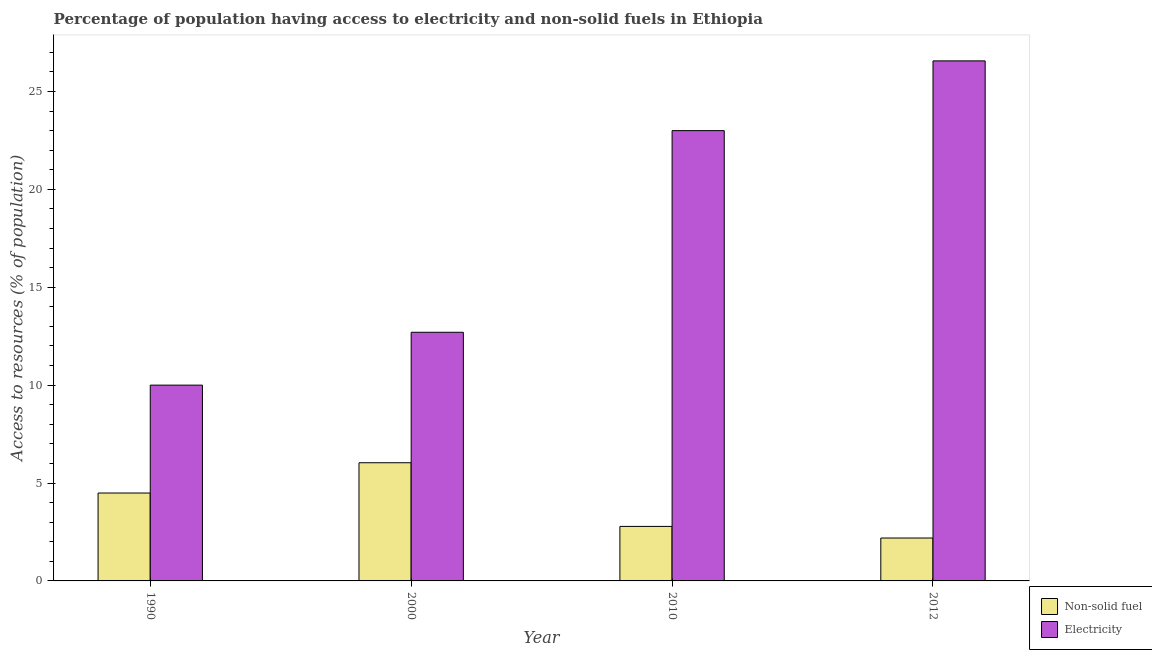Are the number of bars on each tick of the X-axis equal?
Your answer should be very brief. Yes. In how many cases, is the number of bars for a given year not equal to the number of legend labels?
Provide a succinct answer. 0. What is the percentage of population having access to non-solid fuel in 2010?
Make the answer very short. 2.78. Across all years, what is the maximum percentage of population having access to electricity?
Ensure brevity in your answer.  26.56. Across all years, what is the minimum percentage of population having access to electricity?
Offer a very short reply. 10. In which year was the percentage of population having access to electricity maximum?
Your response must be concise. 2012. What is the total percentage of population having access to non-solid fuel in the graph?
Provide a succinct answer. 15.5. What is the difference between the percentage of population having access to non-solid fuel in 1990 and that in 2012?
Ensure brevity in your answer.  2.3. What is the difference between the percentage of population having access to non-solid fuel in 1990 and the percentage of population having access to electricity in 2012?
Keep it short and to the point. 2.3. What is the average percentage of population having access to electricity per year?
Provide a succinct answer. 18.07. What is the ratio of the percentage of population having access to electricity in 1990 to that in 2012?
Your answer should be very brief. 0.38. What is the difference between the highest and the second highest percentage of population having access to non-solid fuel?
Ensure brevity in your answer.  1.55. What is the difference between the highest and the lowest percentage of population having access to electricity?
Offer a terse response. 16.56. In how many years, is the percentage of population having access to non-solid fuel greater than the average percentage of population having access to non-solid fuel taken over all years?
Provide a short and direct response. 2. What does the 2nd bar from the left in 2000 represents?
Provide a succinct answer. Electricity. What does the 2nd bar from the right in 1990 represents?
Offer a terse response. Non-solid fuel. How many bars are there?
Your answer should be very brief. 8. Are the values on the major ticks of Y-axis written in scientific E-notation?
Provide a succinct answer. No. Does the graph contain any zero values?
Offer a very short reply. No. How are the legend labels stacked?
Make the answer very short. Vertical. What is the title of the graph?
Provide a succinct answer. Percentage of population having access to electricity and non-solid fuels in Ethiopia. Does "Education" appear as one of the legend labels in the graph?
Offer a terse response. No. What is the label or title of the X-axis?
Your response must be concise. Year. What is the label or title of the Y-axis?
Keep it short and to the point. Access to resources (% of population). What is the Access to resources (% of population) in Non-solid fuel in 1990?
Your answer should be very brief. 4.49. What is the Access to resources (% of population) of Electricity in 1990?
Keep it short and to the point. 10. What is the Access to resources (% of population) of Non-solid fuel in 2000?
Your answer should be very brief. 6.04. What is the Access to resources (% of population) in Non-solid fuel in 2010?
Offer a terse response. 2.78. What is the Access to resources (% of population) of Electricity in 2010?
Offer a very short reply. 23. What is the Access to resources (% of population) in Non-solid fuel in 2012?
Your answer should be compact. 2.19. What is the Access to resources (% of population) of Electricity in 2012?
Your answer should be very brief. 26.56. Across all years, what is the maximum Access to resources (% of population) of Non-solid fuel?
Your answer should be compact. 6.04. Across all years, what is the maximum Access to resources (% of population) of Electricity?
Provide a short and direct response. 26.56. Across all years, what is the minimum Access to resources (% of population) in Non-solid fuel?
Offer a very short reply. 2.19. What is the total Access to resources (% of population) in Non-solid fuel in the graph?
Give a very brief answer. 15.5. What is the total Access to resources (% of population) in Electricity in the graph?
Make the answer very short. 72.26. What is the difference between the Access to resources (% of population) in Non-solid fuel in 1990 and that in 2000?
Provide a succinct answer. -1.55. What is the difference between the Access to resources (% of population) of Non-solid fuel in 1990 and that in 2010?
Your answer should be very brief. 1.71. What is the difference between the Access to resources (% of population) of Electricity in 1990 and that in 2010?
Offer a terse response. -13. What is the difference between the Access to resources (% of population) in Non-solid fuel in 1990 and that in 2012?
Your answer should be very brief. 2.3. What is the difference between the Access to resources (% of population) of Electricity in 1990 and that in 2012?
Your response must be concise. -16.56. What is the difference between the Access to resources (% of population) of Non-solid fuel in 2000 and that in 2010?
Provide a short and direct response. 3.25. What is the difference between the Access to resources (% of population) in Non-solid fuel in 2000 and that in 2012?
Keep it short and to the point. 3.84. What is the difference between the Access to resources (% of population) of Electricity in 2000 and that in 2012?
Ensure brevity in your answer.  -13.86. What is the difference between the Access to resources (% of population) in Non-solid fuel in 2010 and that in 2012?
Give a very brief answer. 0.59. What is the difference between the Access to resources (% of population) in Electricity in 2010 and that in 2012?
Keep it short and to the point. -3.56. What is the difference between the Access to resources (% of population) in Non-solid fuel in 1990 and the Access to resources (% of population) in Electricity in 2000?
Provide a succinct answer. -8.21. What is the difference between the Access to resources (% of population) in Non-solid fuel in 1990 and the Access to resources (% of population) in Electricity in 2010?
Your response must be concise. -18.51. What is the difference between the Access to resources (% of population) in Non-solid fuel in 1990 and the Access to resources (% of population) in Electricity in 2012?
Keep it short and to the point. -22.07. What is the difference between the Access to resources (% of population) of Non-solid fuel in 2000 and the Access to resources (% of population) of Electricity in 2010?
Ensure brevity in your answer.  -16.96. What is the difference between the Access to resources (% of population) in Non-solid fuel in 2000 and the Access to resources (% of population) in Electricity in 2012?
Ensure brevity in your answer.  -20.53. What is the difference between the Access to resources (% of population) in Non-solid fuel in 2010 and the Access to resources (% of population) in Electricity in 2012?
Keep it short and to the point. -23.78. What is the average Access to resources (% of population) in Non-solid fuel per year?
Provide a short and direct response. 3.88. What is the average Access to resources (% of population) of Electricity per year?
Keep it short and to the point. 18.07. In the year 1990, what is the difference between the Access to resources (% of population) of Non-solid fuel and Access to resources (% of population) of Electricity?
Provide a succinct answer. -5.51. In the year 2000, what is the difference between the Access to resources (% of population) of Non-solid fuel and Access to resources (% of population) of Electricity?
Ensure brevity in your answer.  -6.66. In the year 2010, what is the difference between the Access to resources (% of population) of Non-solid fuel and Access to resources (% of population) of Electricity?
Your answer should be very brief. -20.22. In the year 2012, what is the difference between the Access to resources (% of population) in Non-solid fuel and Access to resources (% of population) in Electricity?
Give a very brief answer. -24.37. What is the ratio of the Access to resources (% of population) in Non-solid fuel in 1990 to that in 2000?
Keep it short and to the point. 0.74. What is the ratio of the Access to resources (% of population) of Electricity in 1990 to that in 2000?
Offer a very short reply. 0.79. What is the ratio of the Access to resources (% of population) of Non-solid fuel in 1990 to that in 2010?
Make the answer very short. 1.61. What is the ratio of the Access to resources (% of population) in Electricity in 1990 to that in 2010?
Keep it short and to the point. 0.43. What is the ratio of the Access to resources (% of population) in Non-solid fuel in 1990 to that in 2012?
Give a very brief answer. 2.05. What is the ratio of the Access to resources (% of population) in Electricity in 1990 to that in 2012?
Give a very brief answer. 0.38. What is the ratio of the Access to resources (% of population) of Non-solid fuel in 2000 to that in 2010?
Make the answer very short. 2.17. What is the ratio of the Access to resources (% of population) of Electricity in 2000 to that in 2010?
Your answer should be very brief. 0.55. What is the ratio of the Access to resources (% of population) of Non-solid fuel in 2000 to that in 2012?
Provide a short and direct response. 2.75. What is the ratio of the Access to resources (% of population) in Electricity in 2000 to that in 2012?
Keep it short and to the point. 0.48. What is the ratio of the Access to resources (% of population) in Non-solid fuel in 2010 to that in 2012?
Provide a short and direct response. 1.27. What is the ratio of the Access to resources (% of population) of Electricity in 2010 to that in 2012?
Provide a short and direct response. 0.87. What is the difference between the highest and the second highest Access to resources (% of population) of Non-solid fuel?
Your answer should be very brief. 1.55. What is the difference between the highest and the second highest Access to resources (% of population) of Electricity?
Offer a very short reply. 3.56. What is the difference between the highest and the lowest Access to resources (% of population) of Non-solid fuel?
Keep it short and to the point. 3.84. What is the difference between the highest and the lowest Access to resources (% of population) of Electricity?
Offer a terse response. 16.56. 